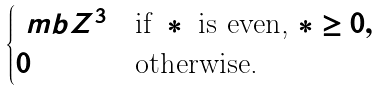Convert formula to latex. <formula><loc_0><loc_0><loc_500><loc_500>\begin{cases} \ m b Z ^ { 3 } & \text {if } * \text { is even, } * \geq 0 , \\ 0 & \text {otherwise.} \end{cases}</formula> 